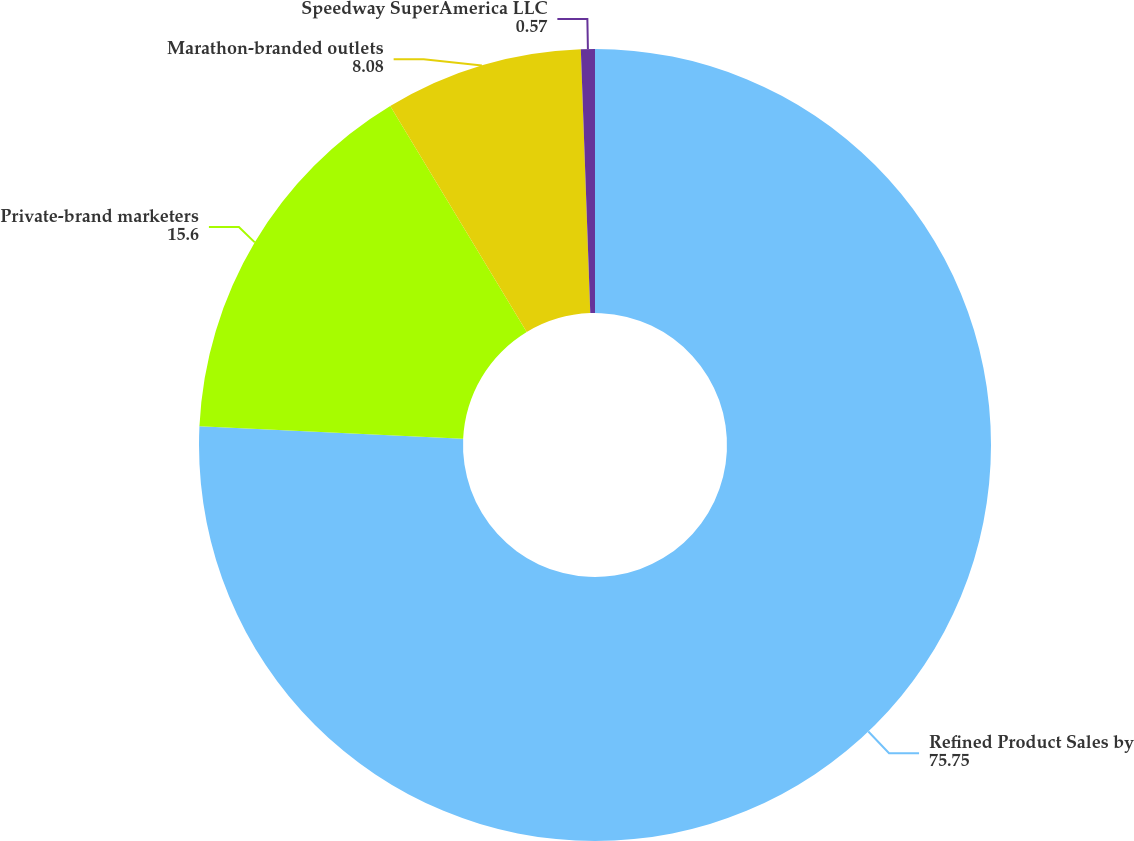Convert chart. <chart><loc_0><loc_0><loc_500><loc_500><pie_chart><fcel>Refined Product Sales by<fcel>Private-brand marketers<fcel>Marathon-branded outlets<fcel>Speedway SuperAmerica LLC<nl><fcel>75.75%<fcel>15.6%<fcel>8.08%<fcel>0.57%<nl></chart> 